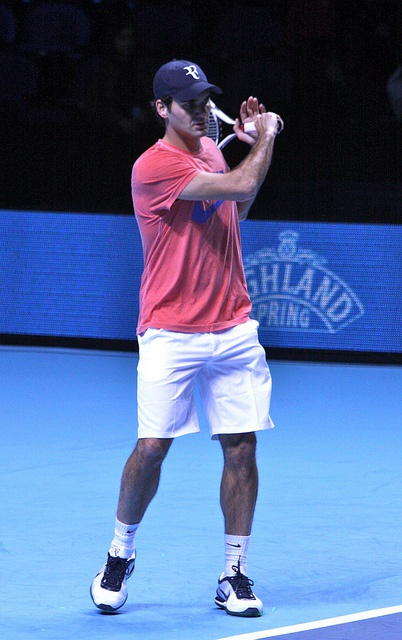Describe the objects in this image and their specific colors. I can see people in black, lavender, purple, violet, and navy tones and tennis racket in black, lavender, gray, and navy tones in this image. 